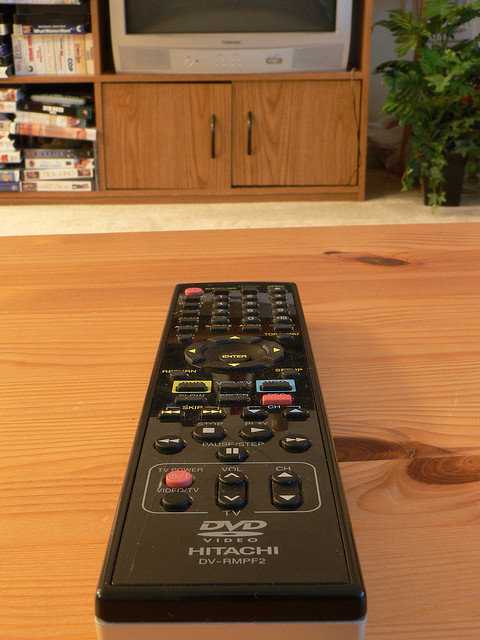Read all the text in this image. TV DVD VIDEO HITACHI RMPF2 CH OH 